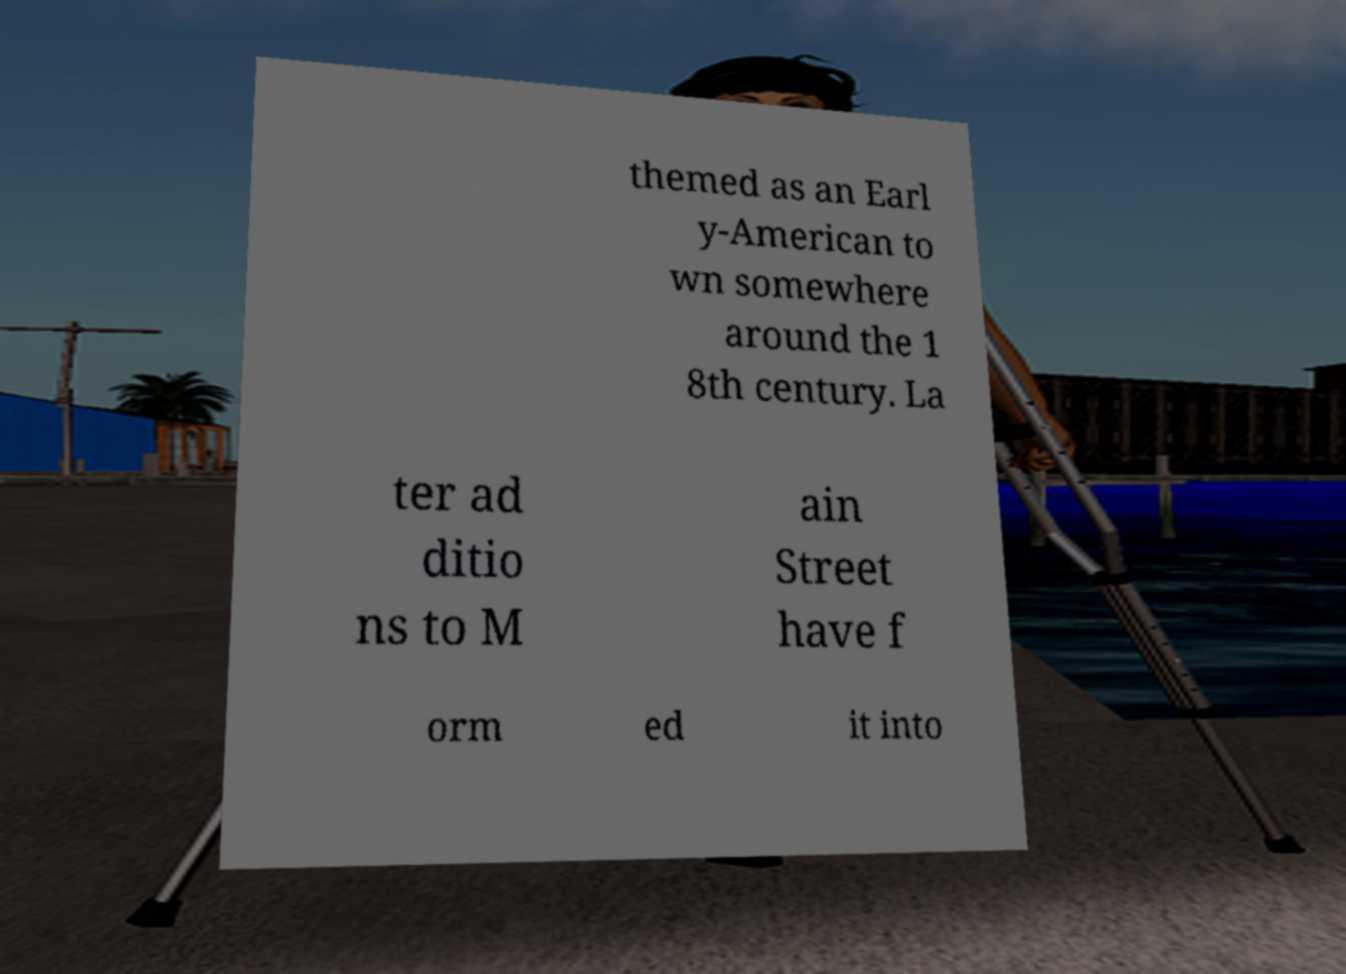Could you extract and type out the text from this image? themed as an Earl y-American to wn somewhere around the 1 8th century. La ter ad ditio ns to M ain Street have f orm ed it into 